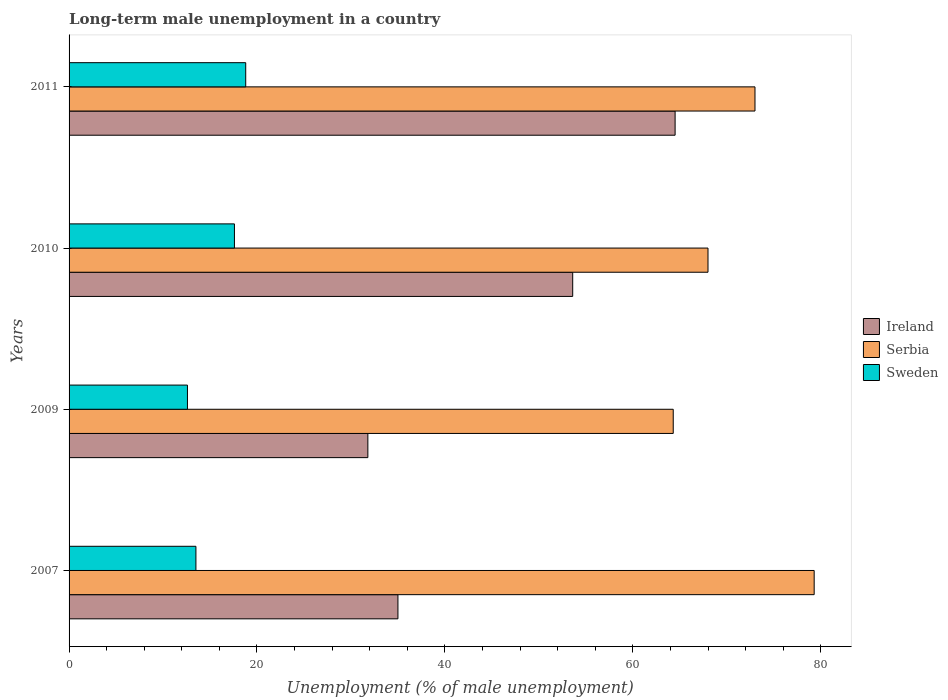Are the number of bars on each tick of the Y-axis equal?
Your answer should be compact. Yes. What is the percentage of long-term unemployed male population in Sweden in 2010?
Ensure brevity in your answer.  17.6. Across all years, what is the maximum percentage of long-term unemployed male population in Ireland?
Keep it short and to the point. 64.5. Across all years, what is the minimum percentage of long-term unemployed male population in Ireland?
Offer a very short reply. 31.8. In which year was the percentage of long-term unemployed male population in Sweden minimum?
Offer a terse response. 2009. What is the total percentage of long-term unemployed male population in Serbia in the graph?
Give a very brief answer. 284.6. What is the difference between the percentage of long-term unemployed male population in Sweden in 2009 and that in 2011?
Your answer should be compact. -6.2. What is the difference between the percentage of long-term unemployed male population in Ireland in 2009 and the percentage of long-term unemployed male population in Sweden in 2011?
Your answer should be very brief. 13. What is the average percentage of long-term unemployed male population in Ireland per year?
Make the answer very short. 46.22. What is the ratio of the percentage of long-term unemployed male population in Sweden in 2007 to that in 2010?
Give a very brief answer. 0.77. What is the difference between the highest and the second highest percentage of long-term unemployed male population in Serbia?
Provide a succinct answer. 6.3. What is the difference between the highest and the lowest percentage of long-term unemployed male population in Serbia?
Provide a short and direct response. 15. What does the 2nd bar from the top in 2009 represents?
Provide a succinct answer. Serbia. What does the 1st bar from the bottom in 2007 represents?
Offer a very short reply. Ireland. Are all the bars in the graph horizontal?
Keep it short and to the point. Yes. What is the difference between two consecutive major ticks on the X-axis?
Ensure brevity in your answer.  20. Does the graph contain grids?
Provide a short and direct response. No. Where does the legend appear in the graph?
Your answer should be very brief. Center right. How are the legend labels stacked?
Give a very brief answer. Vertical. What is the title of the graph?
Offer a very short reply. Long-term male unemployment in a country. Does "Lao PDR" appear as one of the legend labels in the graph?
Your answer should be compact. No. What is the label or title of the X-axis?
Make the answer very short. Unemployment (% of male unemployment). What is the Unemployment (% of male unemployment) of Serbia in 2007?
Provide a succinct answer. 79.3. What is the Unemployment (% of male unemployment) of Ireland in 2009?
Make the answer very short. 31.8. What is the Unemployment (% of male unemployment) in Serbia in 2009?
Your answer should be very brief. 64.3. What is the Unemployment (% of male unemployment) of Sweden in 2009?
Offer a very short reply. 12.6. What is the Unemployment (% of male unemployment) in Ireland in 2010?
Provide a short and direct response. 53.6. What is the Unemployment (% of male unemployment) of Sweden in 2010?
Offer a terse response. 17.6. What is the Unemployment (% of male unemployment) of Ireland in 2011?
Provide a short and direct response. 64.5. What is the Unemployment (% of male unemployment) in Sweden in 2011?
Ensure brevity in your answer.  18.8. Across all years, what is the maximum Unemployment (% of male unemployment) of Ireland?
Provide a succinct answer. 64.5. Across all years, what is the maximum Unemployment (% of male unemployment) in Serbia?
Provide a succinct answer. 79.3. Across all years, what is the maximum Unemployment (% of male unemployment) in Sweden?
Keep it short and to the point. 18.8. Across all years, what is the minimum Unemployment (% of male unemployment) of Ireland?
Keep it short and to the point. 31.8. Across all years, what is the minimum Unemployment (% of male unemployment) in Serbia?
Your response must be concise. 64.3. Across all years, what is the minimum Unemployment (% of male unemployment) in Sweden?
Provide a succinct answer. 12.6. What is the total Unemployment (% of male unemployment) in Ireland in the graph?
Your answer should be compact. 184.9. What is the total Unemployment (% of male unemployment) in Serbia in the graph?
Ensure brevity in your answer.  284.6. What is the total Unemployment (% of male unemployment) in Sweden in the graph?
Ensure brevity in your answer.  62.5. What is the difference between the Unemployment (% of male unemployment) of Serbia in 2007 and that in 2009?
Offer a very short reply. 15. What is the difference between the Unemployment (% of male unemployment) in Ireland in 2007 and that in 2010?
Your answer should be very brief. -18.6. What is the difference between the Unemployment (% of male unemployment) of Ireland in 2007 and that in 2011?
Offer a very short reply. -29.5. What is the difference between the Unemployment (% of male unemployment) in Serbia in 2007 and that in 2011?
Your answer should be very brief. 6.3. What is the difference between the Unemployment (% of male unemployment) in Sweden in 2007 and that in 2011?
Make the answer very short. -5.3. What is the difference between the Unemployment (% of male unemployment) of Ireland in 2009 and that in 2010?
Your answer should be very brief. -21.8. What is the difference between the Unemployment (% of male unemployment) of Sweden in 2009 and that in 2010?
Your response must be concise. -5. What is the difference between the Unemployment (% of male unemployment) of Ireland in 2009 and that in 2011?
Your answer should be compact. -32.7. What is the difference between the Unemployment (% of male unemployment) in Ireland in 2010 and that in 2011?
Your answer should be very brief. -10.9. What is the difference between the Unemployment (% of male unemployment) of Serbia in 2010 and that in 2011?
Make the answer very short. -5. What is the difference between the Unemployment (% of male unemployment) in Ireland in 2007 and the Unemployment (% of male unemployment) in Serbia in 2009?
Ensure brevity in your answer.  -29.3. What is the difference between the Unemployment (% of male unemployment) of Ireland in 2007 and the Unemployment (% of male unemployment) of Sweden in 2009?
Offer a very short reply. 22.4. What is the difference between the Unemployment (% of male unemployment) in Serbia in 2007 and the Unemployment (% of male unemployment) in Sweden in 2009?
Give a very brief answer. 66.7. What is the difference between the Unemployment (% of male unemployment) in Ireland in 2007 and the Unemployment (% of male unemployment) in Serbia in 2010?
Provide a succinct answer. -33. What is the difference between the Unemployment (% of male unemployment) of Ireland in 2007 and the Unemployment (% of male unemployment) of Sweden in 2010?
Give a very brief answer. 17.4. What is the difference between the Unemployment (% of male unemployment) in Serbia in 2007 and the Unemployment (% of male unemployment) in Sweden in 2010?
Provide a succinct answer. 61.7. What is the difference between the Unemployment (% of male unemployment) in Ireland in 2007 and the Unemployment (% of male unemployment) in Serbia in 2011?
Offer a very short reply. -38. What is the difference between the Unemployment (% of male unemployment) in Serbia in 2007 and the Unemployment (% of male unemployment) in Sweden in 2011?
Make the answer very short. 60.5. What is the difference between the Unemployment (% of male unemployment) in Ireland in 2009 and the Unemployment (% of male unemployment) in Serbia in 2010?
Make the answer very short. -36.2. What is the difference between the Unemployment (% of male unemployment) in Ireland in 2009 and the Unemployment (% of male unemployment) in Sweden in 2010?
Offer a terse response. 14.2. What is the difference between the Unemployment (% of male unemployment) of Serbia in 2009 and the Unemployment (% of male unemployment) of Sweden in 2010?
Ensure brevity in your answer.  46.7. What is the difference between the Unemployment (% of male unemployment) in Ireland in 2009 and the Unemployment (% of male unemployment) in Serbia in 2011?
Give a very brief answer. -41.2. What is the difference between the Unemployment (% of male unemployment) in Ireland in 2009 and the Unemployment (% of male unemployment) in Sweden in 2011?
Provide a succinct answer. 13. What is the difference between the Unemployment (% of male unemployment) in Serbia in 2009 and the Unemployment (% of male unemployment) in Sweden in 2011?
Your answer should be very brief. 45.5. What is the difference between the Unemployment (% of male unemployment) in Ireland in 2010 and the Unemployment (% of male unemployment) in Serbia in 2011?
Ensure brevity in your answer.  -19.4. What is the difference between the Unemployment (% of male unemployment) in Ireland in 2010 and the Unemployment (% of male unemployment) in Sweden in 2011?
Give a very brief answer. 34.8. What is the difference between the Unemployment (% of male unemployment) in Serbia in 2010 and the Unemployment (% of male unemployment) in Sweden in 2011?
Offer a terse response. 49.2. What is the average Unemployment (% of male unemployment) of Ireland per year?
Ensure brevity in your answer.  46.23. What is the average Unemployment (% of male unemployment) in Serbia per year?
Your answer should be compact. 71.15. What is the average Unemployment (% of male unemployment) of Sweden per year?
Make the answer very short. 15.62. In the year 2007, what is the difference between the Unemployment (% of male unemployment) of Ireland and Unemployment (% of male unemployment) of Serbia?
Keep it short and to the point. -44.3. In the year 2007, what is the difference between the Unemployment (% of male unemployment) of Ireland and Unemployment (% of male unemployment) of Sweden?
Your answer should be very brief. 21.5. In the year 2007, what is the difference between the Unemployment (% of male unemployment) in Serbia and Unemployment (% of male unemployment) in Sweden?
Your answer should be very brief. 65.8. In the year 2009, what is the difference between the Unemployment (% of male unemployment) of Ireland and Unemployment (% of male unemployment) of Serbia?
Keep it short and to the point. -32.5. In the year 2009, what is the difference between the Unemployment (% of male unemployment) of Ireland and Unemployment (% of male unemployment) of Sweden?
Ensure brevity in your answer.  19.2. In the year 2009, what is the difference between the Unemployment (% of male unemployment) of Serbia and Unemployment (% of male unemployment) of Sweden?
Offer a terse response. 51.7. In the year 2010, what is the difference between the Unemployment (% of male unemployment) in Ireland and Unemployment (% of male unemployment) in Serbia?
Offer a very short reply. -14.4. In the year 2010, what is the difference between the Unemployment (% of male unemployment) in Ireland and Unemployment (% of male unemployment) in Sweden?
Your answer should be compact. 36. In the year 2010, what is the difference between the Unemployment (% of male unemployment) of Serbia and Unemployment (% of male unemployment) of Sweden?
Ensure brevity in your answer.  50.4. In the year 2011, what is the difference between the Unemployment (% of male unemployment) in Ireland and Unemployment (% of male unemployment) in Sweden?
Provide a succinct answer. 45.7. In the year 2011, what is the difference between the Unemployment (% of male unemployment) of Serbia and Unemployment (% of male unemployment) of Sweden?
Keep it short and to the point. 54.2. What is the ratio of the Unemployment (% of male unemployment) of Ireland in 2007 to that in 2009?
Your answer should be compact. 1.1. What is the ratio of the Unemployment (% of male unemployment) in Serbia in 2007 to that in 2009?
Your answer should be very brief. 1.23. What is the ratio of the Unemployment (% of male unemployment) in Sweden in 2007 to that in 2009?
Provide a succinct answer. 1.07. What is the ratio of the Unemployment (% of male unemployment) of Ireland in 2007 to that in 2010?
Your answer should be compact. 0.65. What is the ratio of the Unemployment (% of male unemployment) of Serbia in 2007 to that in 2010?
Ensure brevity in your answer.  1.17. What is the ratio of the Unemployment (% of male unemployment) in Sweden in 2007 to that in 2010?
Make the answer very short. 0.77. What is the ratio of the Unemployment (% of male unemployment) in Ireland in 2007 to that in 2011?
Offer a very short reply. 0.54. What is the ratio of the Unemployment (% of male unemployment) in Serbia in 2007 to that in 2011?
Provide a succinct answer. 1.09. What is the ratio of the Unemployment (% of male unemployment) of Sweden in 2007 to that in 2011?
Offer a very short reply. 0.72. What is the ratio of the Unemployment (% of male unemployment) of Ireland in 2009 to that in 2010?
Provide a succinct answer. 0.59. What is the ratio of the Unemployment (% of male unemployment) of Serbia in 2009 to that in 2010?
Make the answer very short. 0.95. What is the ratio of the Unemployment (% of male unemployment) in Sweden in 2009 to that in 2010?
Offer a terse response. 0.72. What is the ratio of the Unemployment (% of male unemployment) in Ireland in 2009 to that in 2011?
Make the answer very short. 0.49. What is the ratio of the Unemployment (% of male unemployment) of Serbia in 2009 to that in 2011?
Ensure brevity in your answer.  0.88. What is the ratio of the Unemployment (% of male unemployment) in Sweden in 2009 to that in 2011?
Your response must be concise. 0.67. What is the ratio of the Unemployment (% of male unemployment) in Ireland in 2010 to that in 2011?
Your answer should be compact. 0.83. What is the ratio of the Unemployment (% of male unemployment) in Serbia in 2010 to that in 2011?
Provide a succinct answer. 0.93. What is the ratio of the Unemployment (% of male unemployment) of Sweden in 2010 to that in 2011?
Offer a terse response. 0.94. What is the difference between the highest and the second highest Unemployment (% of male unemployment) in Ireland?
Your answer should be compact. 10.9. What is the difference between the highest and the second highest Unemployment (% of male unemployment) of Serbia?
Your response must be concise. 6.3. What is the difference between the highest and the second highest Unemployment (% of male unemployment) of Sweden?
Offer a terse response. 1.2. What is the difference between the highest and the lowest Unemployment (% of male unemployment) of Ireland?
Give a very brief answer. 32.7. What is the difference between the highest and the lowest Unemployment (% of male unemployment) in Serbia?
Make the answer very short. 15. What is the difference between the highest and the lowest Unemployment (% of male unemployment) in Sweden?
Your answer should be compact. 6.2. 